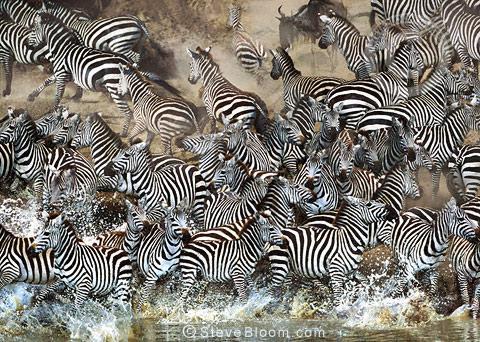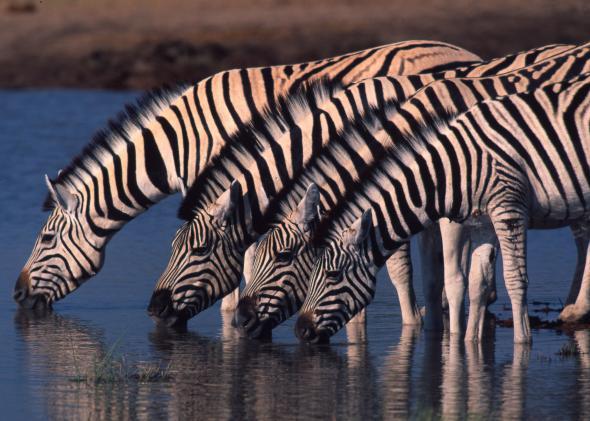The first image is the image on the left, the second image is the image on the right. Given the left and right images, does the statement "More than three zebras can be seen drinking water." hold true? Answer yes or no. Yes. The first image is the image on the left, the second image is the image on the right. For the images displayed, is the sentence "Both images show zebras standing in water." factually correct? Answer yes or no. Yes. 